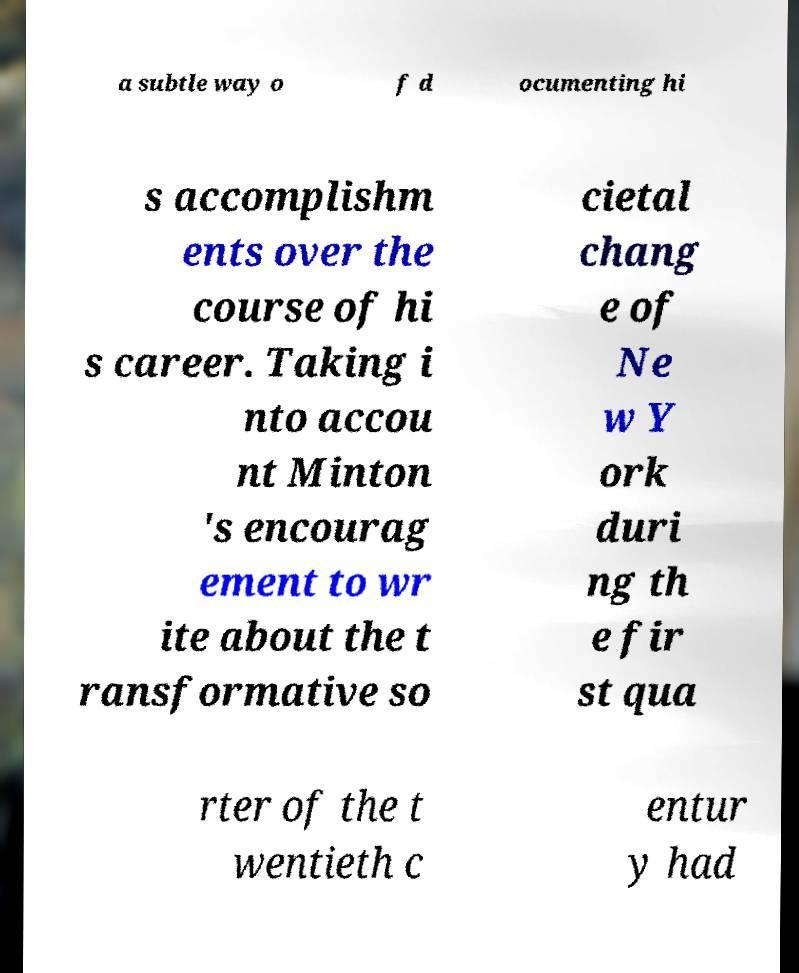Please identify and transcribe the text found in this image. a subtle way o f d ocumenting hi s accomplishm ents over the course of hi s career. Taking i nto accou nt Minton 's encourag ement to wr ite about the t ransformative so cietal chang e of Ne w Y ork duri ng th e fir st qua rter of the t wentieth c entur y had 